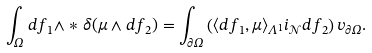Convert formula to latex. <formula><loc_0><loc_0><loc_500><loc_500>\int _ { \Omega } d f _ { 1 } \wedge \ast \delta ( \mu \wedge d f _ { 2 } ) = \int _ { \partial \Omega } \left ( \langle d f _ { 1 } , \mu \rangle _ { \Lambda ^ { 1 } } i _ { \mathcal { N } } d f _ { 2 } \right ) v _ { \partial \Omega } .</formula> 